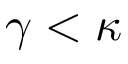<formula> <loc_0><loc_0><loc_500><loc_500>\gamma < \kappa</formula> 